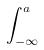Convert formula to latex. <formula><loc_0><loc_0><loc_500><loc_500>\int _ { - \infty } ^ { a }</formula> 